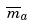Convert formula to latex. <formula><loc_0><loc_0><loc_500><loc_500>\overline { m } _ { a }</formula> 